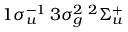<formula> <loc_0><loc_0><loc_500><loc_500>1 \sigma _ { u } ^ { - 1 } \, 3 \sigma _ { g } ^ { 2 } \, ^ { 2 } \Sigma _ { u } ^ { + }</formula> 